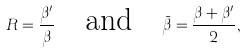<formula> <loc_0><loc_0><loc_500><loc_500>R = \frac { \beta ^ { \prime } } { \beta } \quad \text {and} \quad \bar { \beta } = \frac { \beta + \beta ^ { \prime } } { 2 } ,</formula> 